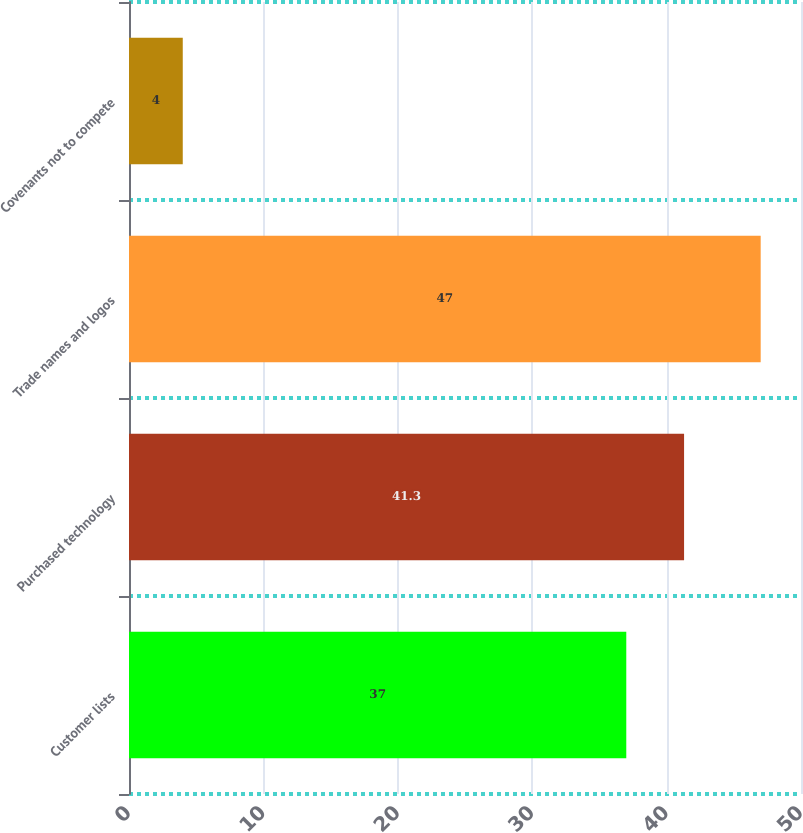Convert chart to OTSL. <chart><loc_0><loc_0><loc_500><loc_500><bar_chart><fcel>Customer lists<fcel>Purchased technology<fcel>Trade names and logos<fcel>Covenants not to compete<nl><fcel>37<fcel>41.3<fcel>47<fcel>4<nl></chart> 